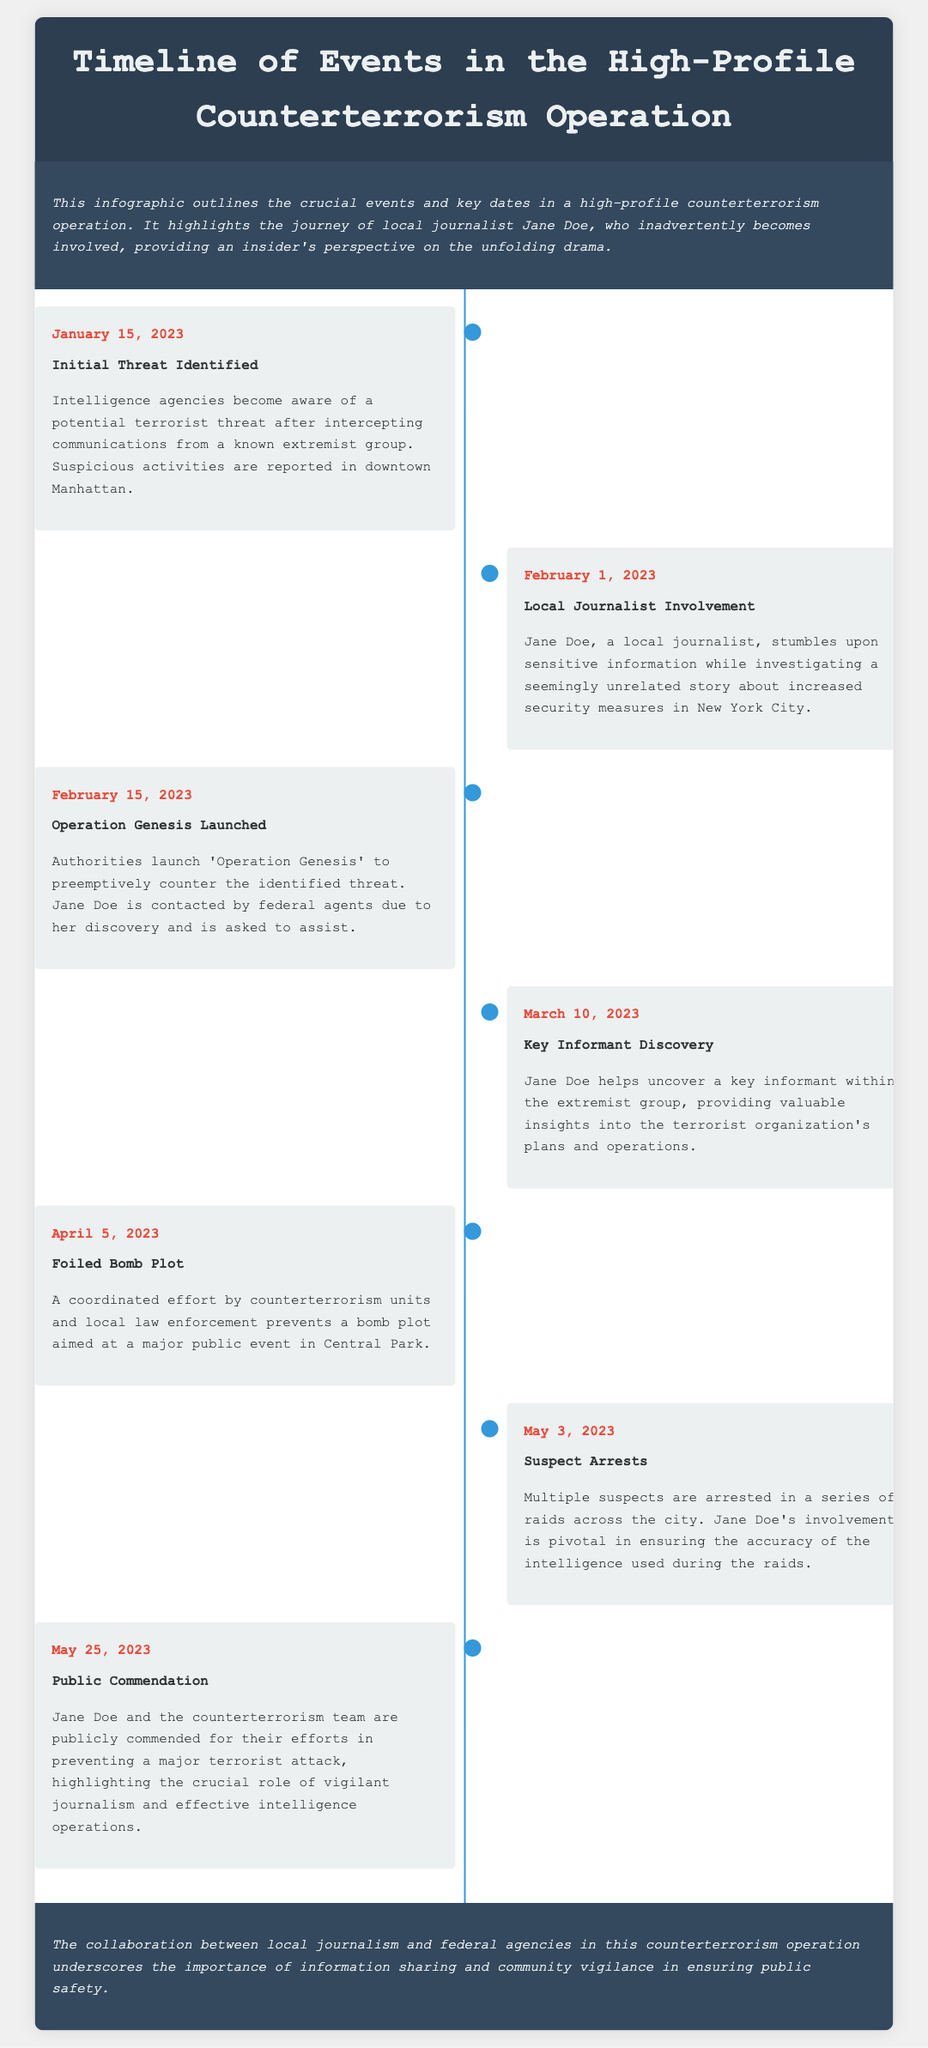what date was the initial threat identified? The date of the initial threat identification is clearly stated in the document.
Answer: January 15, 2023 who is the local journalist involved in the operation? The document specifically mentions the name of the local journalist involved in the counterterrorism operation.
Answer: Jane Doe what is the title of the operation launched to counter the threat? The title of the operation is outlined in the timeline section of the document.
Answer: Operation Genesis what significant event occurred on March 10, 2023? The event on this date is detailed in the timeline, outlining Jane Doe's contribution.
Answer: Key Informant Discovery how many arrests were made on May 3, 2023? The document mentions the series of raids and subsequent arrests but does not specify a number.
Answer: Multiple what type of plot was foiled on April 5, 2023? The specific type of plot prevented is described alongside the date of the event in the timeline.
Answer: Bomb Plot what aspect of journalism is highlighted by Jane Doe's involvement? The document emphasizes the importance of a specific aspect of journalism in the counterterrorism context.
Answer: Vigilant journalism what commendation was given on May 25, 2023? The kind of recognition received on this date is mentioned towards the end of the timeline.
Answer: Public Commendation 